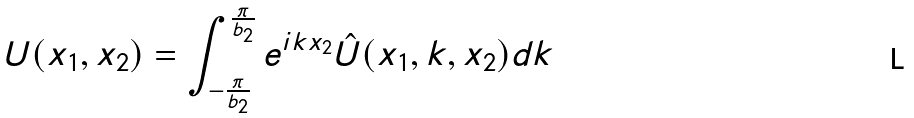<formula> <loc_0><loc_0><loc_500><loc_500>U ( x _ { 1 } , x _ { 2 } ) = \int _ { - \frac { \pi } { b _ { 2 } } } ^ { \frac { \pi } { b _ { 2 } } } e ^ { i k x _ { 2 } } \hat { U } ( x _ { 1 } , k , x _ { 2 } ) d k</formula> 